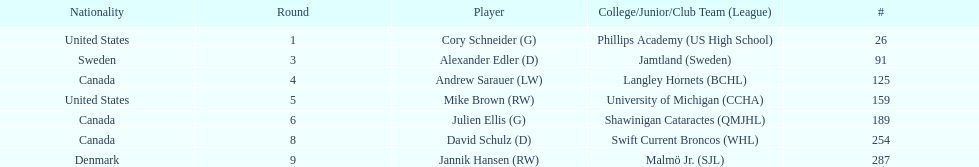How many goalies drafted? 2. 